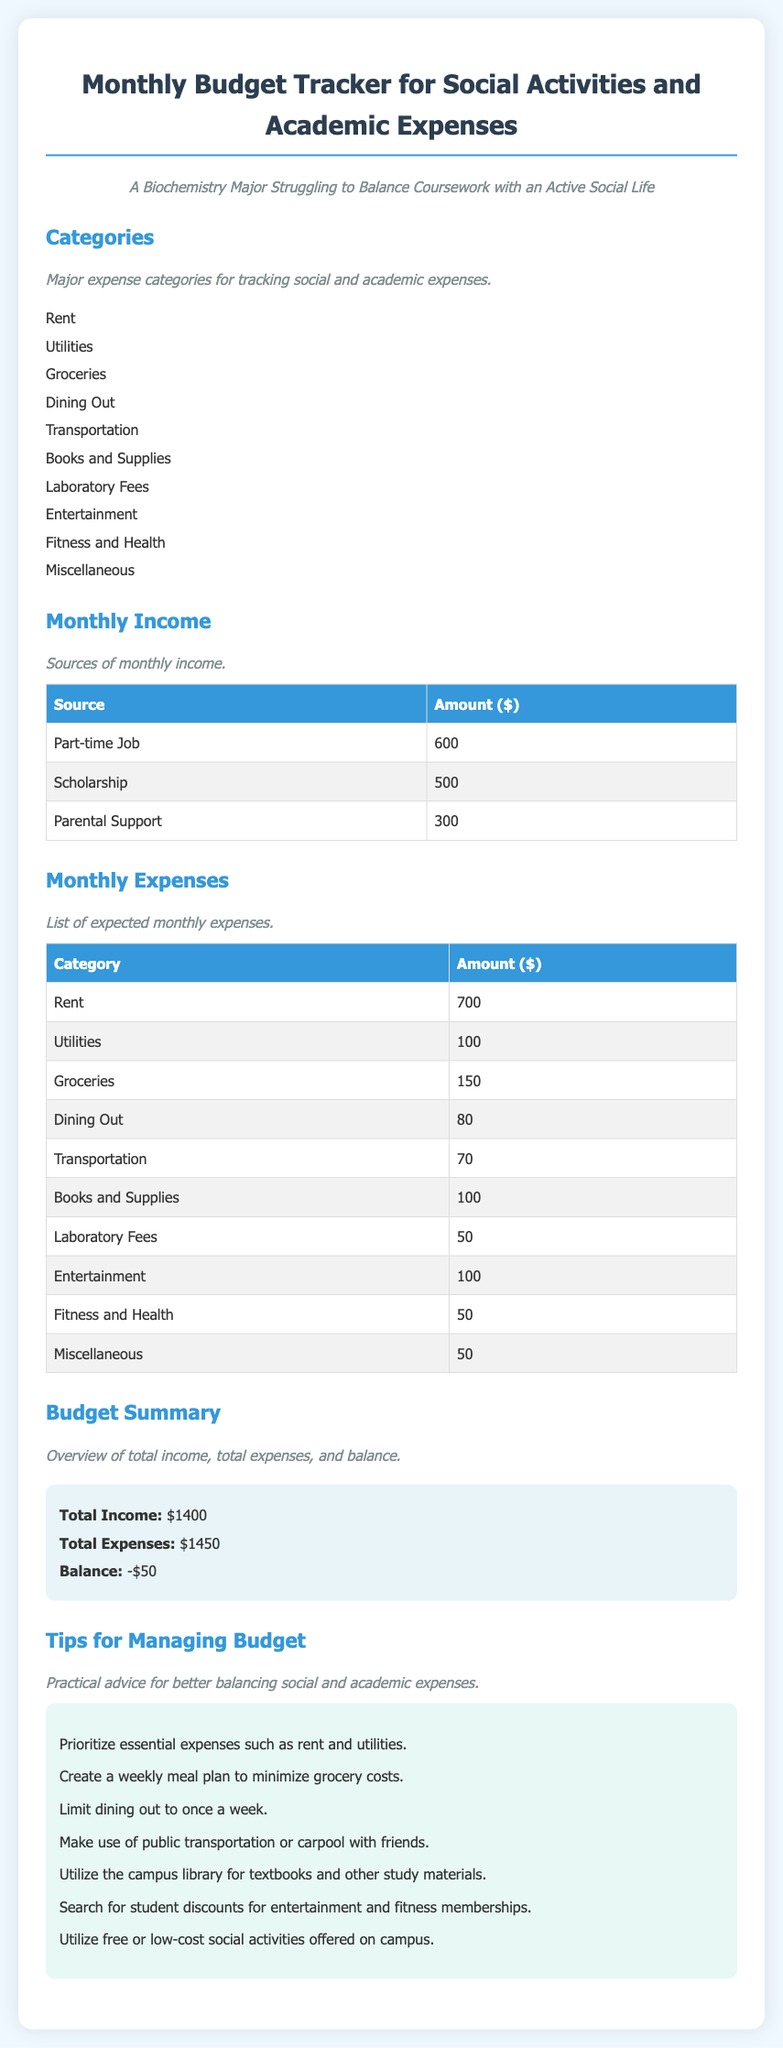what is the total income? The total income is the sum of all income sources in the document: 600, 500, and 300, which equals $1400.
Answer: $1400 what is the largest monthly expense category? The largest monthly expense category listed in the document is rent, which is $700.
Answer: Rent how much is spent on dining out? The monthly expense listed for dining out is $80.
Answer: $80 what is the total amount for books and supplies? The amount listed for books and supplies in the monthly expenses is $100.
Answer: $100 what is the monthly balance? The monthly balance is calculated as total income minus total expenses, which results in -$50.
Answer: -$50 what is the amount allocated for transportation? The document states that the amount allocated for transportation is $70.
Answer: $70 how many sources of monthly income are listed? The document lists three sources of monthly income: Part-time Job, Scholarship, and Parental Support.
Answer: 3 which category shows a cost of $50 in the monthly expenses? The categories for Laboratory Fees and Fitness and Health both show a cost of $50.
Answer: Laboratory Fees and Fitness and Health what type of document is this? The document is a Monthly Budget Tracker, specifically for tracking social activities and academic expenses.
Answer: Monthly Budget Tracker 